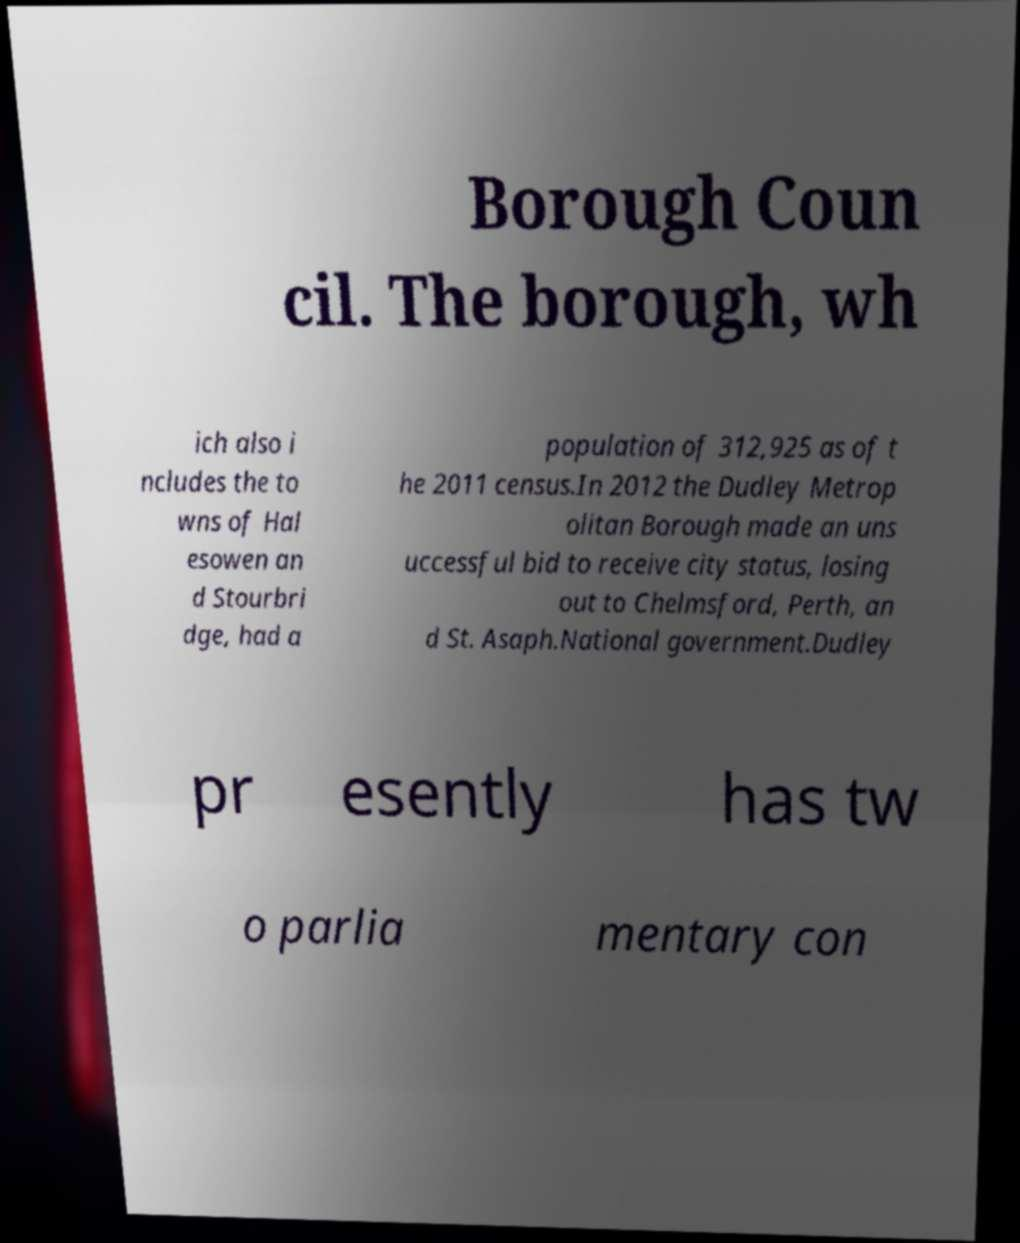Could you assist in decoding the text presented in this image and type it out clearly? Borough Coun cil. The borough, wh ich also i ncludes the to wns of Hal esowen an d Stourbri dge, had a population of 312,925 as of t he 2011 census.In 2012 the Dudley Metrop olitan Borough made an uns uccessful bid to receive city status, losing out to Chelmsford, Perth, an d St. Asaph.National government.Dudley pr esently has tw o parlia mentary con 